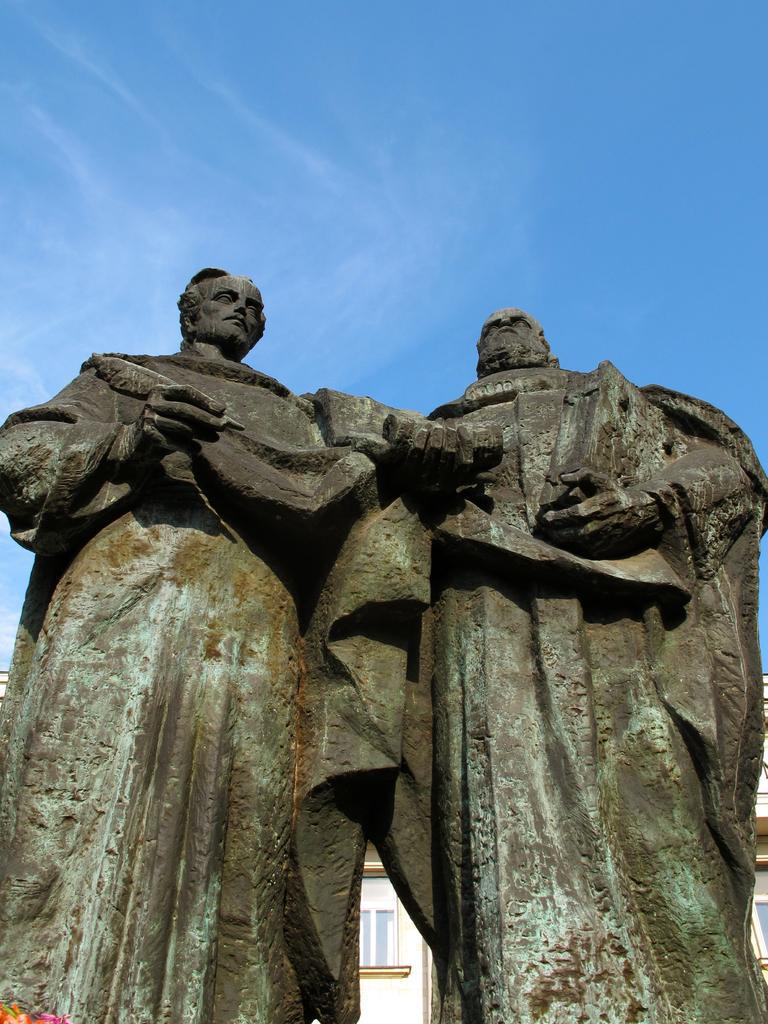In one or two sentences, can you explain what this image depicts? This image consists of statutes. There is building at the bottom. There is sky at the top. 